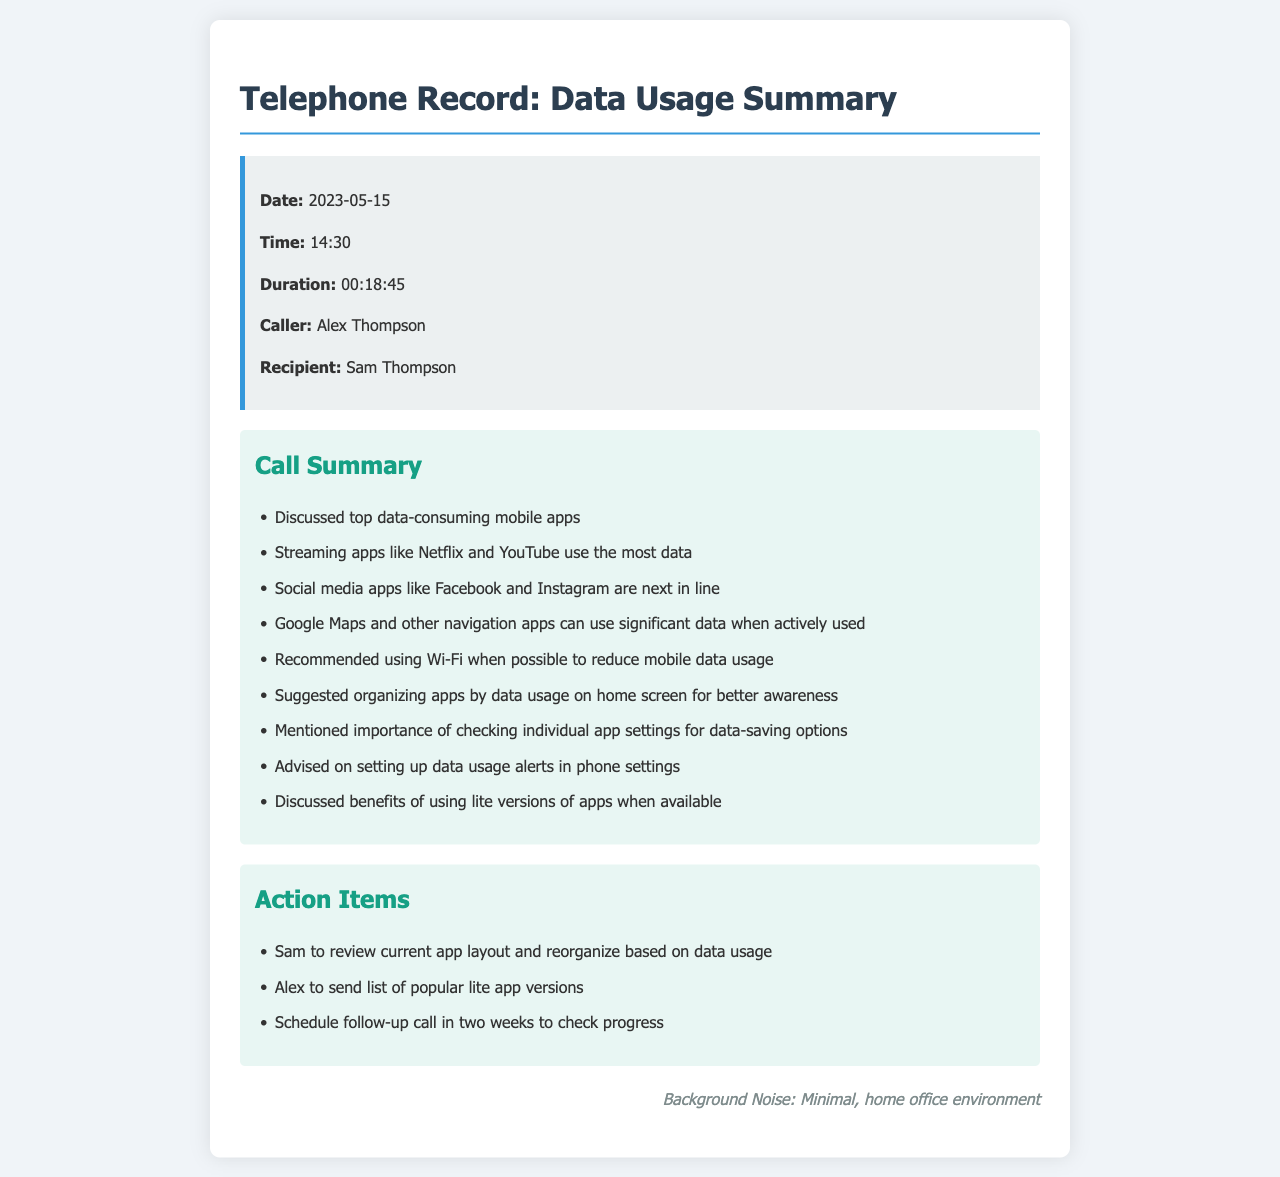what is the date of the call? The date of the call is stated in the call information section of the document.
Answer: 2023-05-15 who was the caller? The caller's name is provided in the call information section.
Answer: Alex Thompson which app was mentioned as using the most data? The document mentions the app that uses the most data in the call summary section.
Answer: Netflix what should Sam do regarding app layout? This action item is specified in the action items section of the document.
Answer: Review current app layout how long was the call? The duration of the call is clearly stated in the call information section.
Answer: 00:18:45 which apps are next in line for consuming data? The document indicates these apps in the call summary section.
Answer: Facebook and Instagram what was a recommended way to reduce mobile data usage? The recommendation to reduce data usage is provided in the call summary.
Answer: Use Wi-Fi how long until the follow-up call is scheduled? The timing of the follow-up call is mentioned in the action items section.
Answer: Two weeks 